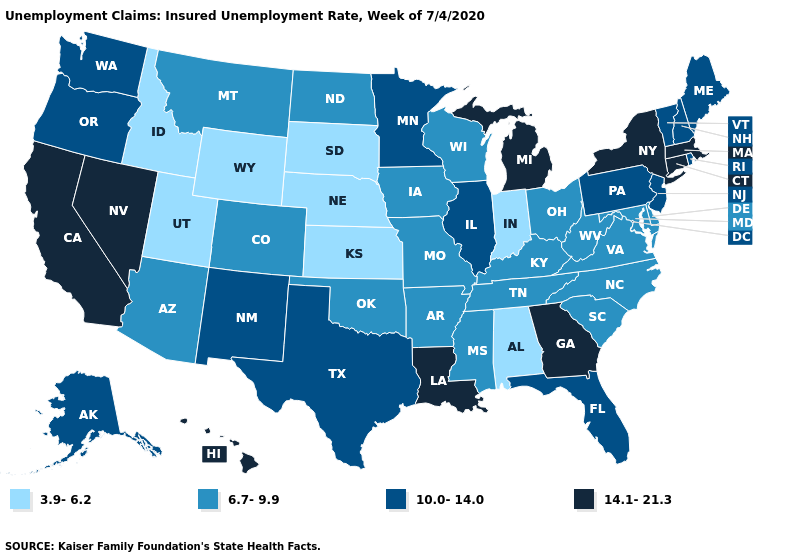How many symbols are there in the legend?
Keep it brief. 4. What is the lowest value in states that border Oregon?
Short answer required. 3.9-6.2. What is the value of Oregon?
Keep it brief. 10.0-14.0. Does Georgia have the highest value in the USA?
Answer briefly. Yes. Name the states that have a value in the range 6.7-9.9?
Short answer required. Arizona, Arkansas, Colorado, Delaware, Iowa, Kentucky, Maryland, Mississippi, Missouri, Montana, North Carolina, North Dakota, Ohio, Oklahoma, South Carolina, Tennessee, Virginia, West Virginia, Wisconsin. Is the legend a continuous bar?
Short answer required. No. Among the states that border Nevada , does California have the highest value?
Be succinct. Yes. Name the states that have a value in the range 6.7-9.9?
Answer briefly. Arizona, Arkansas, Colorado, Delaware, Iowa, Kentucky, Maryland, Mississippi, Missouri, Montana, North Carolina, North Dakota, Ohio, Oklahoma, South Carolina, Tennessee, Virginia, West Virginia, Wisconsin. What is the lowest value in states that border North Dakota?
Quick response, please. 3.9-6.2. Among the states that border Michigan , which have the lowest value?
Keep it brief. Indiana. Which states have the lowest value in the USA?
Be succinct. Alabama, Idaho, Indiana, Kansas, Nebraska, South Dakota, Utah, Wyoming. Does California have the highest value in the USA?
Give a very brief answer. Yes. What is the value of Colorado?
Keep it brief. 6.7-9.9. Name the states that have a value in the range 14.1-21.3?
Be succinct. California, Connecticut, Georgia, Hawaii, Louisiana, Massachusetts, Michigan, Nevada, New York. Does Pennsylvania have the same value as Michigan?
Keep it brief. No. 